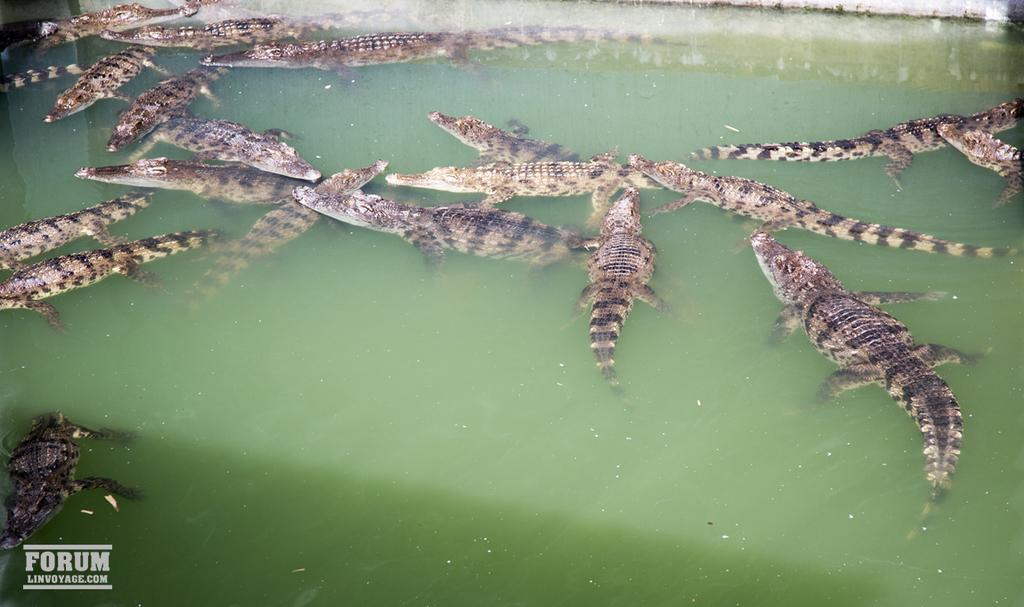What type of animals can be seen in the water in the image? There are crocodiles in the water in the image. Can you describe any additional elements in the image? Yes, there is a watermark in the bottom left corner of the image. What type of glass can be seen in the image? There is no glass present in the image. How does the jelly interact with the crocodiles in the image? There is no jelly present in the image, so it cannot interact with the crocodiles. 